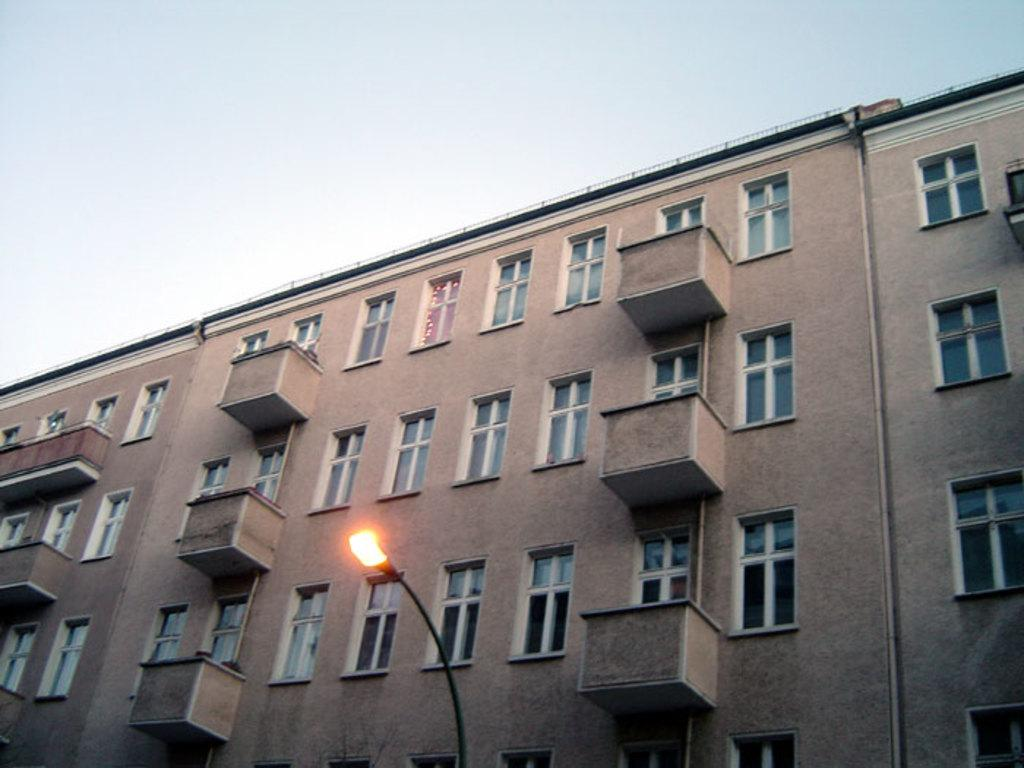What type of structure is in the image? There is a building in the image. What feature can be observed on the building? The building has glass windows. What is located in the center of the image? There is a street light pole in the center of the image. What is visible at the top of the image? The sky is visible at the top of the image. How many bricks make up the flock of birds in the image? There are no birds or bricks present in the image. What time of day is depicted in the image? The time of day cannot be determined from the image, as there are no specific clues or indicators present. 